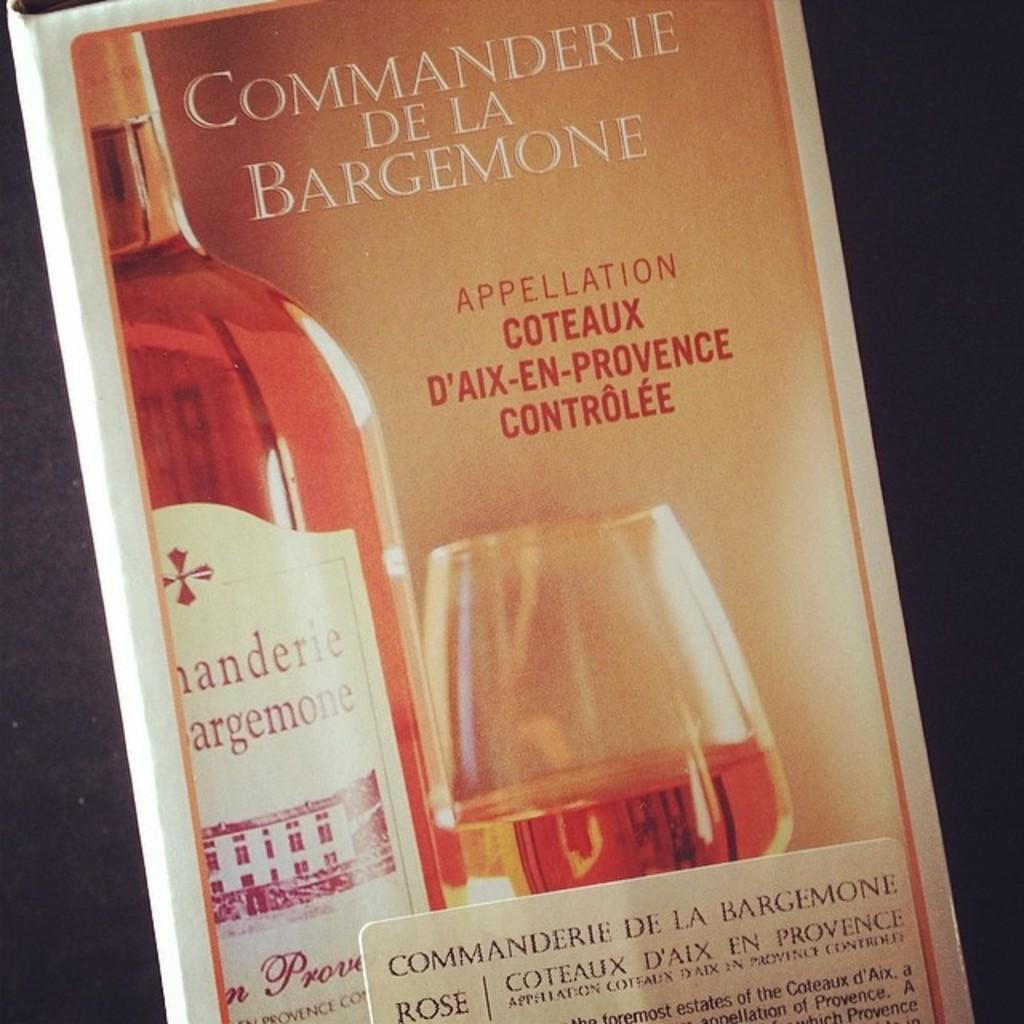What object can be seen in the image that is typically used for storage or packaging? There is a cardboard box in the image. What is visible on the surface of the cardboard box? There is writing on the cardboard box. What type of apparel is being worn by the fish in the image? There are no fish or apparel present in the image; it only features a cardboard box with writing on it. 